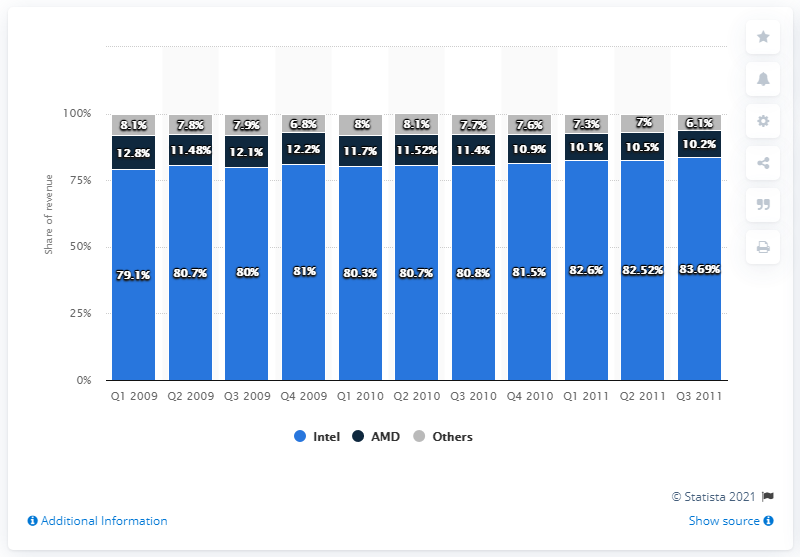Give some essential details in this illustration. In the first quarter of 2009, Intel's global market share was 79.1%. 